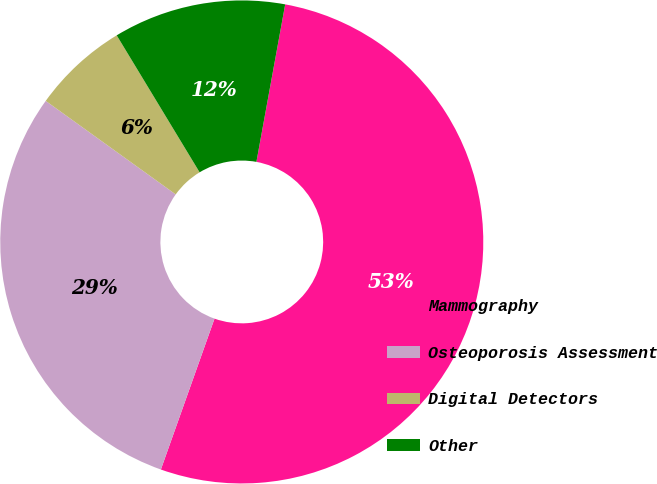Convert chart to OTSL. <chart><loc_0><loc_0><loc_500><loc_500><pie_chart><fcel>Mammography<fcel>Osteoporosis Assessment<fcel>Digital Detectors<fcel>Other<nl><fcel>52.56%<fcel>29.49%<fcel>6.41%<fcel>11.54%<nl></chart> 